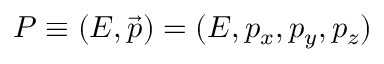Convert formula to latex. <formula><loc_0><loc_0><loc_500><loc_500>P \equiv ( E , { \vec { p } } ) = ( E , p _ { x } , p _ { y } , p _ { z } )</formula> 